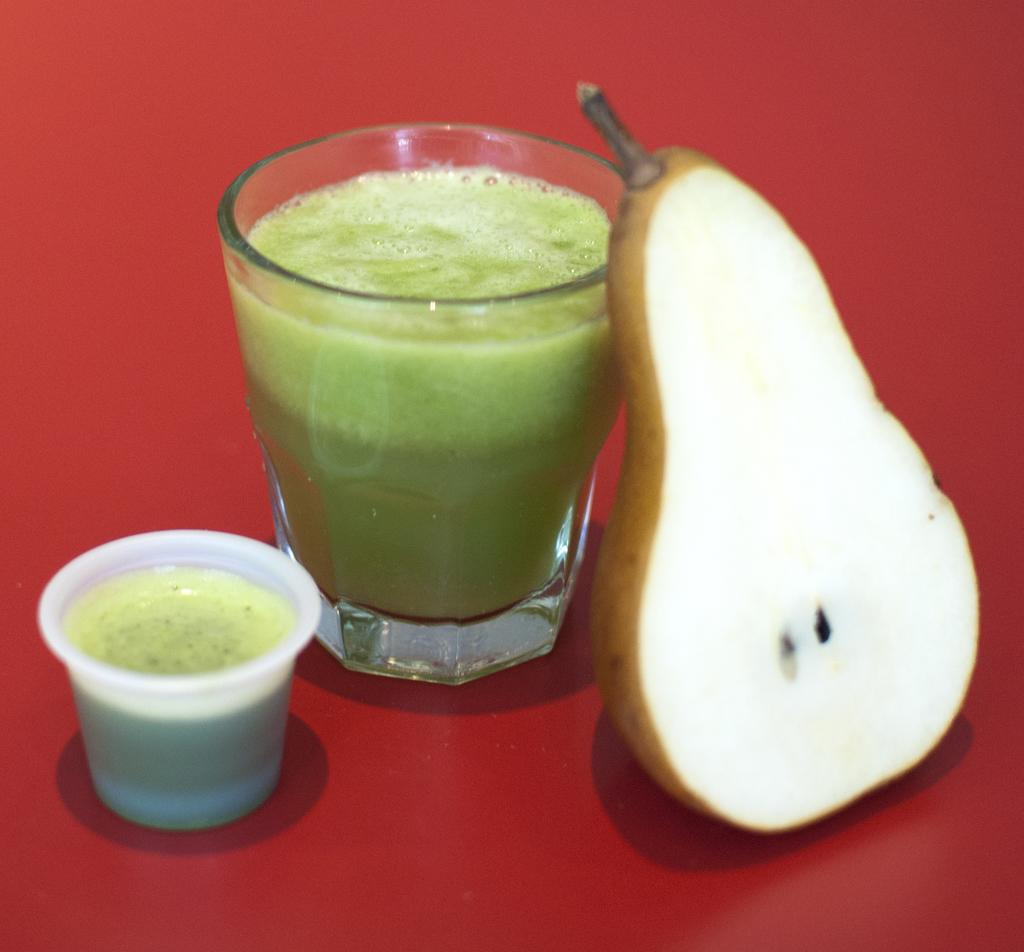What type of fruit is present in the image? There is a piece of pear fruit in the image. How many glasses are visible in the image? There are two glasses in the image. What is inside the glasses? There is juice in the glasses. What color is the surface at the bottom of the image? The surface at the bottom of the image is red in color. Where is the drawer located in the image? There is no drawer present in the image. What type of seat can be seen in the image? There is no seat present in the image. 